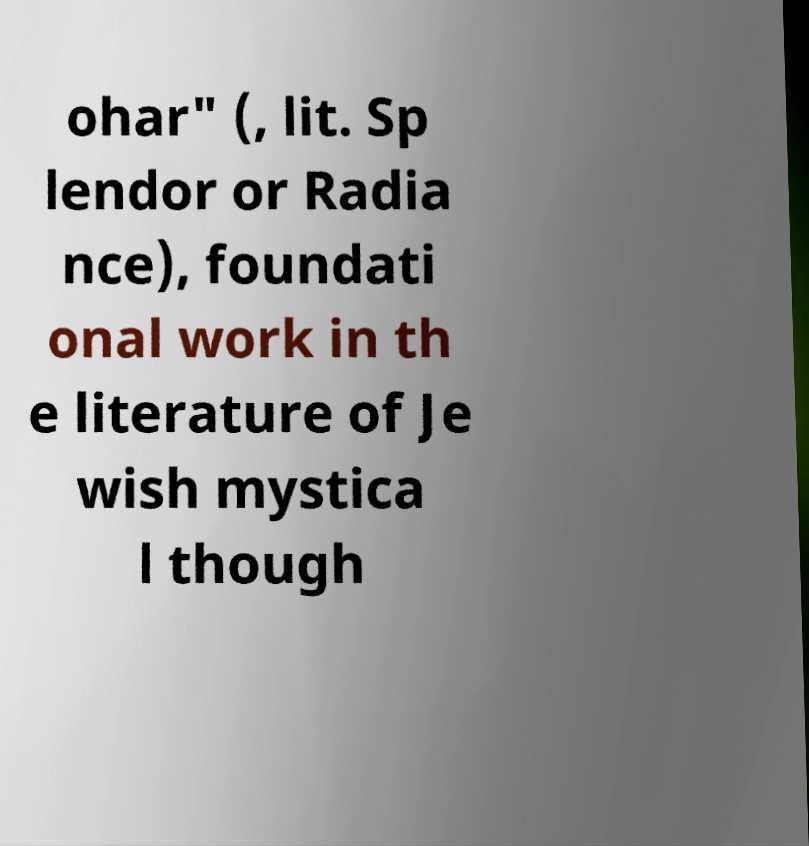For documentation purposes, I need the text within this image transcribed. Could you provide that? ohar" (, lit. Sp lendor or Radia nce), foundati onal work in th e literature of Je wish mystica l though 